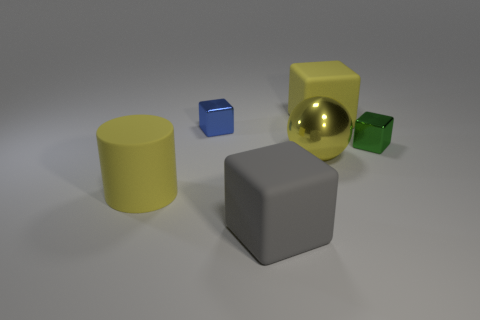Add 4 yellow metallic objects. How many objects exist? 10 Subtract all cylinders. How many objects are left? 5 Add 3 large gray rubber cylinders. How many large gray rubber cylinders exist? 3 Subtract 1 gray blocks. How many objects are left? 5 Subtract all big yellow rubber cubes. Subtract all yellow matte cylinders. How many objects are left? 4 Add 1 big matte cylinders. How many big matte cylinders are left? 2 